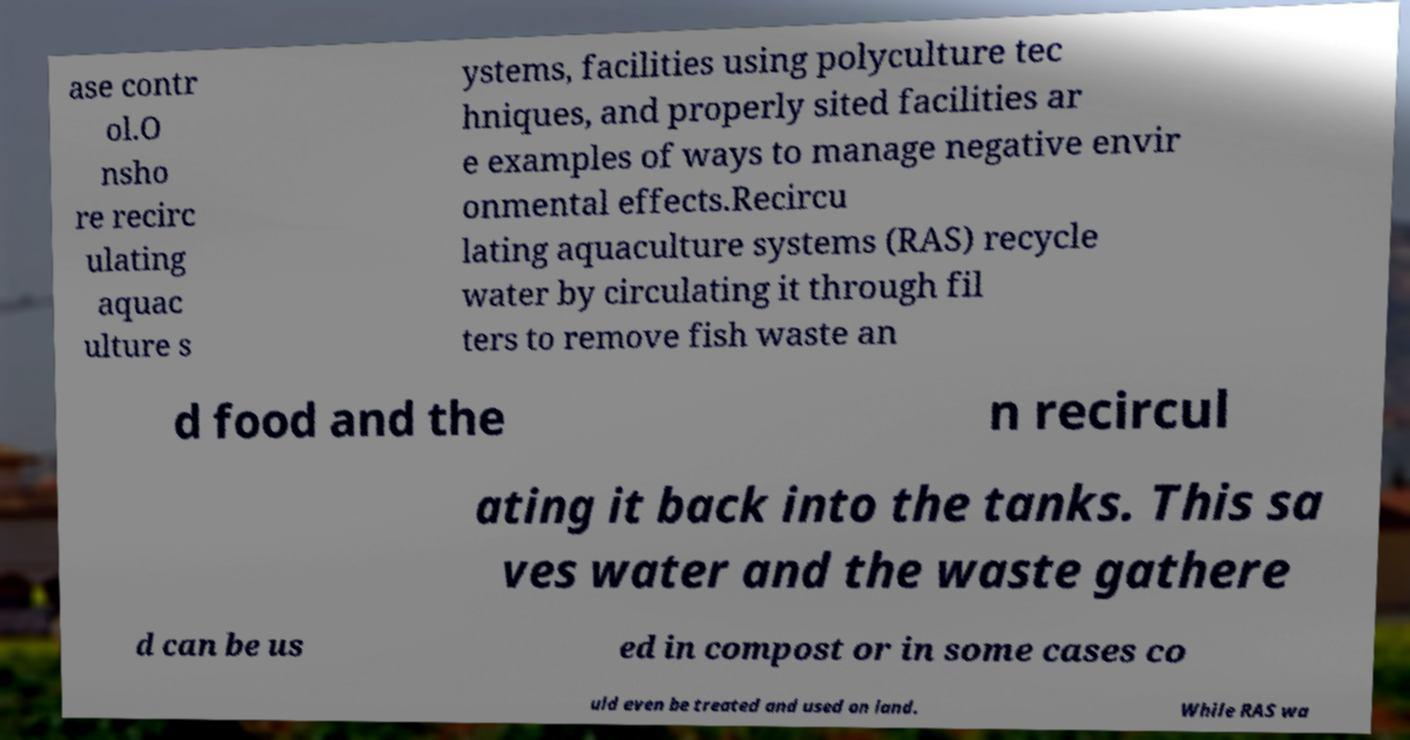There's text embedded in this image that I need extracted. Can you transcribe it verbatim? ase contr ol.O nsho re recirc ulating aquac ulture s ystems, facilities using polyculture tec hniques, and properly sited facilities ar e examples of ways to manage negative envir onmental effects.Recircu lating aquaculture systems (RAS) recycle water by circulating it through fil ters to remove fish waste an d food and the n recircul ating it back into the tanks. This sa ves water and the waste gathere d can be us ed in compost or in some cases co uld even be treated and used on land. While RAS wa 